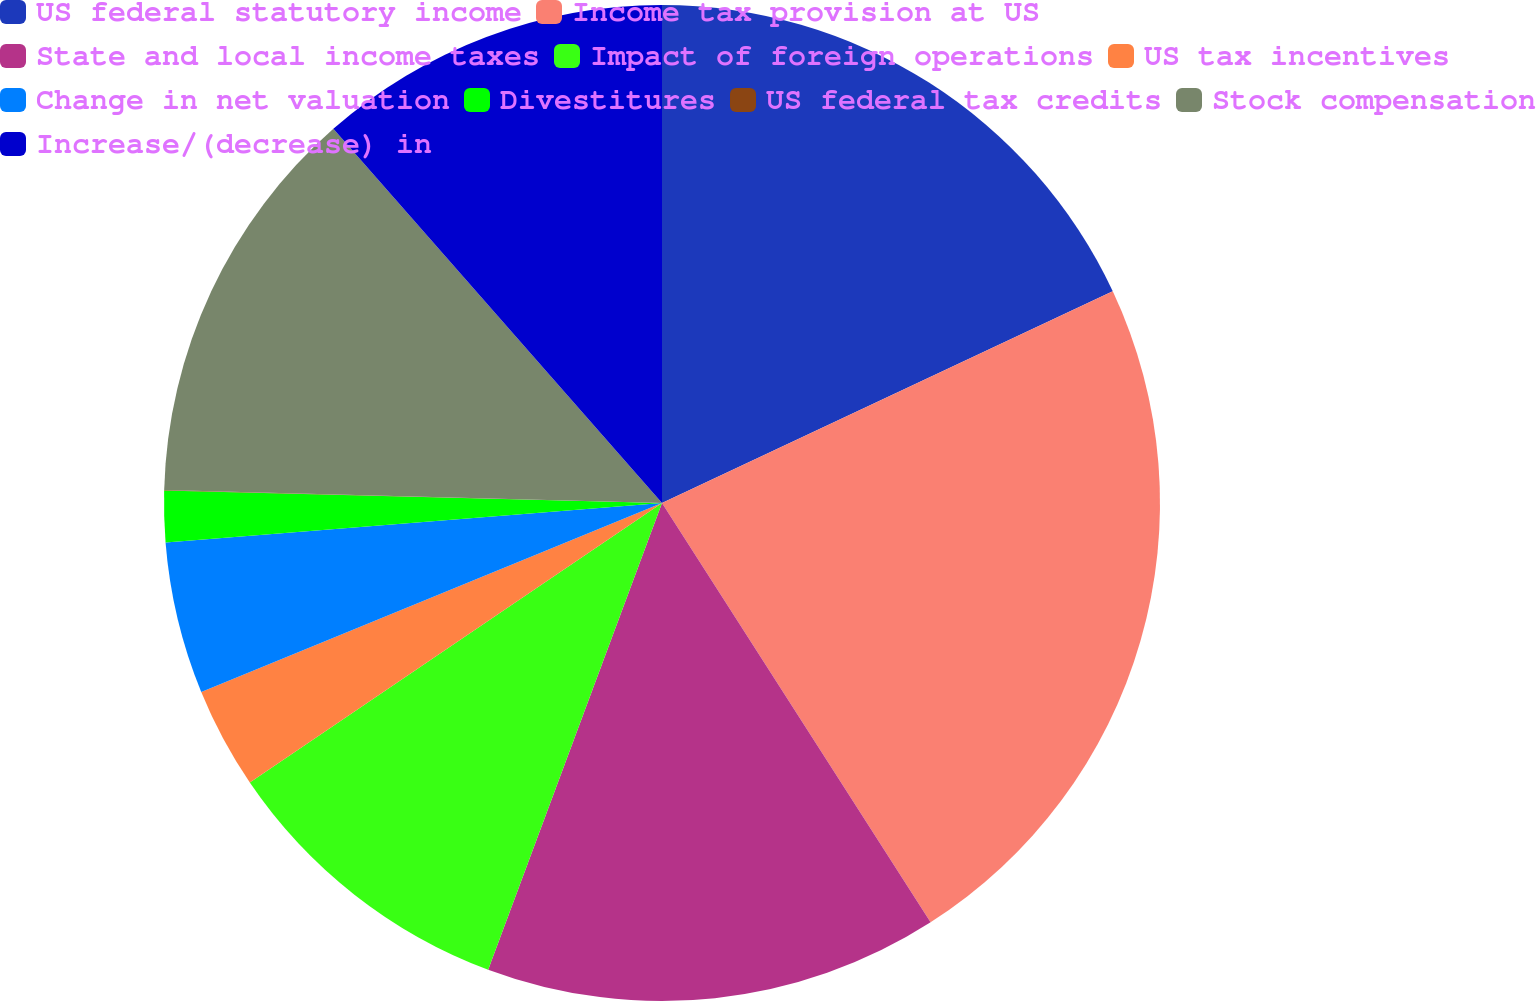<chart> <loc_0><loc_0><loc_500><loc_500><pie_chart><fcel>US federal statutory income<fcel>Income tax provision at US<fcel>State and local income taxes<fcel>Impact of foreign operations<fcel>US tax incentives<fcel>Change in net valuation<fcel>Divestitures<fcel>US federal tax credits<fcel>Stock compensation<fcel>Increase/(decrease) in<nl><fcel>18.01%<fcel>22.92%<fcel>14.74%<fcel>9.84%<fcel>3.29%<fcel>4.93%<fcel>1.66%<fcel>0.02%<fcel>13.11%<fcel>11.47%<nl></chart> 